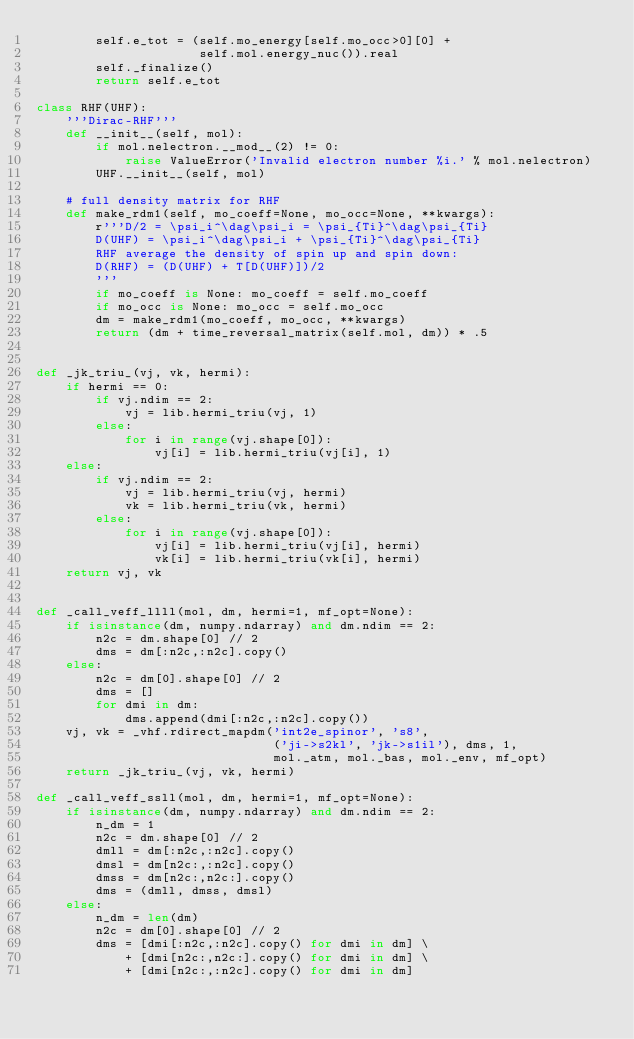<code> <loc_0><loc_0><loc_500><loc_500><_Python_>        self.e_tot = (self.mo_energy[self.mo_occ>0][0] +
                      self.mol.energy_nuc()).real
        self._finalize()
        return self.e_tot

class RHF(UHF):
    '''Dirac-RHF'''
    def __init__(self, mol):
        if mol.nelectron.__mod__(2) != 0:
            raise ValueError('Invalid electron number %i.' % mol.nelectron)
        UHF.__init__(self, mol)

    # full density matrix for RHF
    def make_rdm1(self, mo_coeff=None, mo_occ=None, **kwargs):
        r'''D/2 = \psi_i^\dag\psi_i = \psi_{Ti}^\dag\psi_{Ti}
        D(UHF) = \psi_i^\dag\psi_i + \psi_{Ti}^\dag\psi_{Ti}
        RHF average the density of spin up and spin down:
        D(RHF) = (D(UHF) + T[D(UHF)])/2
        '''
        if mo_coeff is None: mo_coeff = self.mo_coeff
        if mo_occ is None: mo_occ = self.mo_occ
        dm = make_rdm1(mo_coeff, mo_occ, **kwargs)
        return (dm + time_reversal_matrix(self.mol, dm)) * .5


def _jk_triu_(vj, vk, hermi):
    if hermi == 0:
        if vj.ndim == 2:
            vj = lib.hermi_triu(vj, 1)
        else:
            for i in range(vj.shape[0]):
                vj[i] = lib.hermi_triu(vj[i], 1)
    else:
        if vj.ndim == 2:
            vj = lib.hermi_triu(vj, hermi)
            vk = lib.hermi_triu(vk, hermi)
        else:
            for i in range(vj.shape[0]):
                vj[i] = lib.hermi_triu(vj[i], hermi)
                vk[i] = lib.hermi_triu(vk[i], hermi)
    return vj, vk


def _call_veff_llll(mol, dm, hermi=1, mf_opt=None):
    if isinstance(dm, numpy.ndarray) and dm.ndim == 2:
        n2c = dm.shape[0] // 2
        dms = dm[:n2c,:n2c].copy()
    else:
        n2c = dm[0].shape[0] // 2
        dms = []
        for dmi in dm:
            dms.append(dmi[:n2c,:n2c].copy())
    vj, vk = _vhf.rdirect_mapdm('int2e_spinor', 's8',
                                ('ji->s2kl', 'jk->s1il'), dms, 1,
                                mol._atm, mol._bas, mol._env, mf_opt)
    return _jk_triu_(vj, vk, hermi)

def _call_veff_ssll(mol, dm, hermi=1, mf_opt=None):
    if isinstance(dm, numpy.ndarray) and dm.ndim == 2:
        n_dm = 1
        n2c = dm.shape[0] // 2
        dmll = dm[:n2c,:n2c].copy()
        dmsl = dm[n2c:,:n2c].copy()
        dmss = dm[n2c:,n2c:].copy()
        dms = (dmll, dmss, dmsl)
    else:
        n_dm = len(dm)
        n2c = dm[0].shape[0] // 2
        dms = [dmi[:n2c,:n2c].copy() for dmi in dm] \
            + [dmi[n2c:,n2c:].copy() for dmi in dm] \
            + [dmi[n2c:,:n2c].copy() for dmi in dm]</code> 